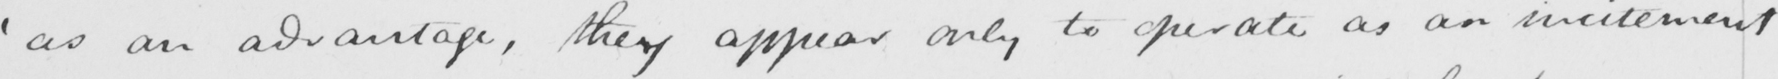Transcribe the text shown in this historical manuscript line. ' as an advantage , they appear only to operate as an incitement 